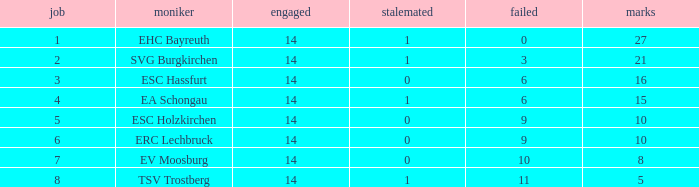What's the lost when there were more than 16 points and had a drawn less than 1? None. 